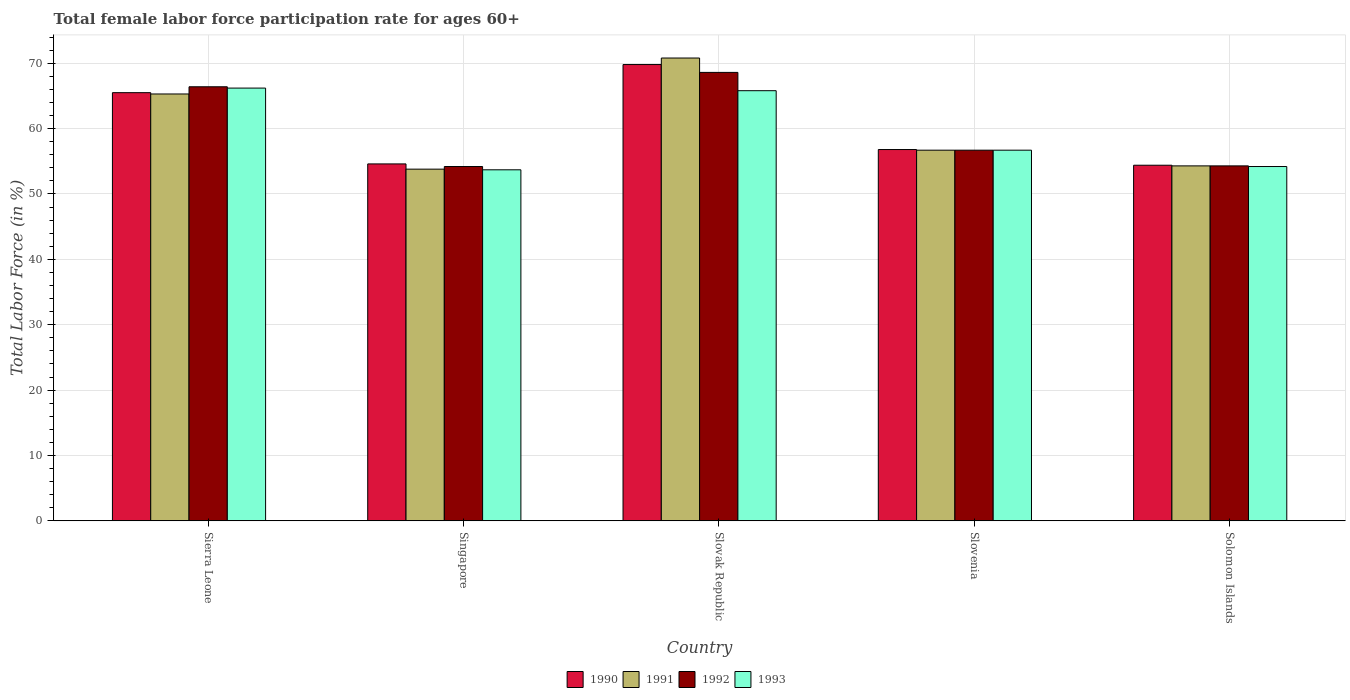How many different coloured bars are there?
Keep it short and to the point. 4. How many bars are there on the 5th tick from the left?
Give a very brief answer. 4. How many bars are there on the 3rd tick from the right?
Give a very brief answer. 4. What is the label of the 1st group of bars from the left?
Provide a succinct answer. Sierra Leone. In how many cases, is the number of bars for a given country not equal to the number of legend labels?
Offer a very short reply. 0. What is the female labor force participation rate in 1990 in Singapore?
Give a very brief answer. 54.6. Across all countries, what is the maximum female labor force participation rate in 1991?
Your answer should be compact. 70.8. Across all countries, what is the minimum female labor force participation rate in 1990?
Offer a very short reply. 54.4. In which country was the female labor force participation rate in 1993 maximum?
Make the answer very short. Sierra Leone. In which country was the female labor force participation rate in 1991 minimum?
Offer a very short reply. Singapore. What is the total female labor force participation rate in 1993 in the graph?
Provide a short and direct response. 296.6. What is the difference between the female labor force participation rate in 1992 in Solomon Islands and the female labor force participation rate in 1990 in Slovenia?
Provide a short and direct response. -2.5. What is the average female labor force participation rate in 1990 per country?
Give a very brief answer. 60.22. What is the difference between the female labor force participation rate of/in 1993 and female labor force participation rate of/in 1992 in Slovenia?
Provide a succinct answer. 0. What is the ratio of the female labor force participation rate in 1990 in Singapore to that in Solomon Islands?
Your answer should be very brief. 1. Is the female labor force participation rate in 1993 in Singapore less than that in Solomon Islands?
Offer a very short reply. Yes. What is the difference between the highest and the second highest female labor force participation rate in 1990?
Provide a short and direct response. -8.7. What is the difference between the highest and the lowest female labor force participation rate in 1991?
Your answer should be compact. 17. In how many countries, is the female labor force participation rate in 1992 greater than the average female labor force participation rate in 1992 taken over all countries?
Ensure brevity in your answer.  2. Is the sum of the female labor force participation rate in 1991 in Singapore and Slovak Republic greater than the maximum female labor force participation rate in 1992 across all countries?
Your answer should be compact. Yes. Is it the case that in every country, the sum of the female labor force participation rate in 1991 and female labor force participation rate in 1993 is greater than the sum of female labor force participation rate in 1992 and female labor force participation rate in 1990?
Make the answer very short. No. What does the 2nd bar from the left in Singapore represents?
Ensure brevity in your answer.  1991. What does the 3rd bar from the right in Solomon Islands represents?
Ensure brevity in your answer.  1991. Is it the case that in every country, the sum of the female labor force participation rate in 1991 and female labor force participation rate in 1993 is greater than the female labor force participation rate in 1992?
Ensure brevity in your answer.  Yes. How many bars are there?
Keep it short and to the point. 20. Are all the bars in the graph horizontal?
Offer a very short reply. No. What is the difference between two consecutive major ticks on the Y-axis?
Provide a succinct answer. 10. Are the values on the major ticks of Y-axis written in scientific E-notation?
Ensure brevity in your answer.  No. Does the graph contain any zero values?
Your answer should be compact. No. How are the legend labels stacked?
Give a very brief answer. Horizontal. What is the title of the graph?
Your answer should be very brief. Total female labor force participation rate for ages 60+. What is the label or title of the X-axis?
Provide a short and direct response. Country. What is the Total Labor Force (in %) in 1990 in Sierra Leone?
Provide a short and direct response. 65.5. What is the Total Labor Force (in %) in 1991 in Sierra Leone?
Ensure brevity in your answer.  65.3. What is the Total Labor Force (in %) of 1992 in Sierra Leone?
Make the answer very short. 66.4. What is the Total Labor Force (in %) in 1993 in Sierra Leone?
Keep it short and to the point. 66.2. What is the Total Labor Force (in %) in 1990 in Singapore?
Your answer should be compact. 54.6. What is the Total Labor Force (in %) of 1991 in Singapore?
Your answer should be compact. 53.8. What is the Total Labor Force (in %) in 1992 in Singapore?
Your answer should be compact. 54.2. What is the Total Labor Force (in %) of 1993 in Singapore?
Give a very brief answer. 53.7. What is the Total Labor Force (in %) in 1990 in Slovak Republic?
Make the answer very short. 69.8. What is the Total Labor Force (in %) of 1991 in Slovak Republic?
Keep it short and to the point. 70.8. What is the Total Labor Force (in %) in 1992 in Slovak Republic?
Provide a succinct answer. 68.6. What is the Total Labor Force (in %) of 1993 in Slovak Republic?
Keep it short and to the point. 65.8. What is the Total Labor Force (in %) in 1990 in Slovenia?
Provide a succinct answer. 56.8. What is the Total Labor Force (in %) in 1991 in Slovenia?
Offer a very short reply. 56.7. What is the Total Labor Force (in %) in 1992 in Slovenia?
Give a very brief answer. 56.7. What is the Total Labor Force (in %) in 1993 in Slovenia?
Provide a succinct answer. 56.7. What is the Total Labor Force (in %) of 1990 in Solomon Islands?
Your answer should be compact. 54.4. What is the Total Labor Force (in %) in 1991 in Solomon Islands?
Provide a succinct answer. 54.3. What is the Total Labor Force (in %) in 1992 in Solomon Islands?
Offer a very short reply. 54.3. What is the Total Labor Force (in %) of 1993 in Solomon Islands?
Keep it short and to the point. 54.2. Across all countries, what is the maximum Total Labor Force (in %) of 1990?
Provide a succinct answer. 69.8. Across all countries, what is the maximum Total Labor Force (in %) in 1991?
Your answer should be compact. 70.8. Across all countries, what is the maximum Total Labor Force (in %) of 1992?
Provide a succinct answer. 68.6. Across all countries, what is the maximum Total Labor Force (in %) of 1993?
Your answer should be compact. 66.2. Across all countries, what is the minimum Total Labor Force (in %) of 1990?
Your response must be concise. 54.4. Across all countries, what is the minimum Total Labor Force (in %) of 1991?
Provide a short and direct response. 53.8. Across all countries, what is the minimum Total Labor Force (in %) in 1992?
Your response must be concise. 54.2. Across all countries, what is the minimum Total Labor Force (in %) of 1993?
Provide a short and direct response. 53.7. What is the total Total Labor Force (in %) of 1990 in the graph?
Ensure brevity in your answer.  301.1. What is the total Total Labor Force (in %) of 1991 in the graph?
Offer a terse response. 300.9. What is the total Total Labor Force (in %) of 1992 in the graph?
Provide a succinct answer. 300.2. What is the total Total Labor Force (in %) in 1993 in the graph?
Provide a short and direct response. 296.6. What is the difference between the Total Labor Force (in %) of 1990 in Sierra Leone and that in Singapore?
Your response must be concise. 10.9. What is the difference between the Total Labor Force (in %) in 1992 in Sierra Leone and that in Singapore?
Offer a very short reply. 12.2. What is the difference between the Total Labor Force (in %) of 1991 in Sierra Leone and that in Slovak Republic?
Your answer should be very brief. -5.5. What is the difference between the Total Labor Force (in %) in 1992 in Sierra Leone and that in Slovak Republic?
Keep it short and to the point. -2.2. What is the difference between the Total Labor Force (in %) of 1993 in Sierra Leone and that in Slovak Republic?
Your response must be concise. 0.4. What is the difference between the Total Labor Force (in %) of 1990 in Sierra Leone and that in Slovenia?
Your response must be concise. 8.7. What is the difference between the Total Labor Force (in %) in 1991 in Sierra Leone and that in Slovenia?
Ensure brevity in your answer.  8.6. What is the difference between the Total Labor Force (in %) in 1992 in Sierra Leone and that in Slovenia?
Your answer should be compact. 9.7. What is the difference between the Total Labor Force (in %) of 1992 in Sierra Leone and that in Solomon Islands?
Ensure brevity in your answer.  12.1. What is the difference between the Total Labor Force (in %) of 1993 in Sierra Leone and that in Solomon Islands?
Ensure brevity in your answer.  12. What is the difference between the Total Labor Force (in %) in 1990 in Singapore and that in Slovak Republic?
Keep it short and to the point. -15.2. What is the difference between the Total Labor Force (in %) of 1991 in Singapore and that in Slovak Republic?
Make the answer very short. -17. What is the difference between the Total Labor Force (in %) of 1992 in Singapore and that in Slovak Republic?
Provide a short and direct response. -14.4. What is the difference between the Total Labor Force (in %) in 1993 in Singapore and that in Slovak Republic?
Ensure brevity in your answer.  -12.1. What is the difference between the Total Labor Force (in %) of 1990 in Singapore and that in Slovenia?
Make the answer very short. -2.2. What is the difference between the Total Labor Force (in %) of 1991 in Singapore and that in Slovenia?
Your answer should be very brief. -2.9. What is the difference between the Total Labor Force (in %) of 1993 in Singapore and that in Slovenia?
Offer a terse response. -3. What is the difference between the Total Labor Force (in %) of 1991 in Singapore and that in Solomon Islands?
Provide a short and direct response. -0.5. What is the difference between the Total Labor Force (in %) of 1992 in Singapore and that in Solomon Islands?
Your answer should be very brief. -0.1. What is the difference between the Total Labor Force (in %) in 1991 in Slovak Republic and that in Slovenia?
Ensure brevity in your answer.  14.1. What is the difference between the Total Labor Force (in %) in 1992 in Slovak Republic and that in Slovenia?
Make the answer very short. 11.9. What is the difference between the Total Labor Force (in %) in 1991 in Slovak Republic and that in Solomon Islands?
Provide a short and direct response. 16.5. What is the difference between the Total Labor Force (in %) of 1991 in Slovenia and that in Solomon Islands?
Make the answer very short. 2.4. What is the difference between the Total Labor Force (in %) in 1992 in Slovenia and that in Solomon Islands?
Your answer should be compact. 2.4. What is the difference between the Total Labor Force (in %) in 1993 in Slovenia and that in Solomon Islands?
Your answer should be very brief. 2.5. What is the difference between the Total Labor Force (in %) in 1990 in Sierra Leone and the Total Labor Force (in %) in 1993 in Singapore?
Your response must be concise. 11.8. What is the difference between the Total Labor Force (in %) in 1990 in Sierra Leone and the Total Labor Force (in %) in 1993 in Slovak Republic?
Keep it short and to the point. -0.3. What is the difference between the Total Labor Force (in %) in 1991 in Sierra Leone and the Total Labor Force (in %) in 1993 in Slovak Republic?
Offer a very short reply. -0.5. What is the difference between the Total Labor Force (in %) in 1990 in Sierra Leone and the Total Labor Force (in %) in 1991 in Slovenia?
Provide a short and direct response. 8.8. What is the difference between the Total Labor Force (in %) of 1990 in Sierra Leone and the Total Labor Force (in %) of 1993 in Slovenia?
Provide a succinct answer. 8.8. What is the difference between the Total Labor Force (in %) in 1991 in Sierra Leone and the Total Labor Force (in %) in 1993 in Slovenia?
Give a very brief answer. 8.6. What is the difference between the Total Labor Force (in %) in 1992 in Sierra Leone and the Total Labor Force (in %) in 1993 in Slovenia?
Keep it short and to the point. 9.7. What is the difference between the Total Labor Force (in %) in 1990 in Sierra Leone and the Total Labor Force (in %) in 1992 in Solomon Islands?
Offer a very short reply. 11.2. What is the difference between the Total Labor Force (in %) in 1990 in Sierra Leone and the Total Labor Force (in %) in 1993 in Solomon Islands?
Your answer should be compact. 11.3. What is the difference between the Total Labor Force (in %) of 1991 in Sierra Leone and the Total Labor Force (in %) of 1993 in Solomon Islands?
Your response must be concise. 11.1. What is the difference between the Total Labor Force (in %) of 1992 in Sierra Leone and the Total Labor Force (in %) of 1993 in Solomon Islands?
Offer a very short reply. 12.2. What is the difference between the Total Labor Force (in %) in 1990 in Singapore and the Total Labor Force (in %) in 1991 in Slovak Republic?
Keep it short and to the point. -16.2. What is the difference between the Total Labor Force (in %) of 1990 in Singapore and the Total Labor Force (in %) of 1992 in Slovak Republic?
Give a very brief answer. -14. What is the difference between the Total Labor Force (in %) of 1990 in Singapore and the Total Labor Force (in %) of 1993 in Slovak Republic?
Keep it short and to the point. -11.2. What is the difference between the Total Labor Force (in %) of 1991 in Singapore and the Total Labor Force (in %) of 1992 in Slovak Republic?
Provide a short and direct response. -14.8. What is the difference between the Total Labor Force (in %) of 1991 in Singapore and the Total Labor Force (in %) of 1993 in Slovak Republic?
Offer a terse response. -12. What is the difference between the Total Labor Force (in %) of 1990 in Singapore and the Total Labor Force (in %) of 1991 in Slovenia?
Offer a terse response. -2.1. What is the difference between the Total Labor Force (in %) of 1990 in Singapore and the Total Labor Force (in %) of 1992 in Slovenia?
Your answer should be compact. -2.1. What is the difference between the Total Labor Force (in %) in 1990 in Singapore and the Total Labor Force (in %) in 1993 in Slovenia?
Give a very brief answer. -2.1. What is the difference between the Total Labor Force (in %) of 1991 in Singapore and the Total Labor Force (in %) of 1992 in Slovenia?
Give a very brief answer. -2.9. What is the difference between the Total Labor Force (in %) in 1991 in Singapore and the Total Labor Force (in %) in 1993 in Slovenia?
Give a very brief answer. -2.9. What is the difference between the Total Labor Force (in %) in 1990 in Singapore and the Total Labor Force (in %) in 1991 in Solomon Islands?
Keep it short and to the point. 0.3. What is the difference between the Total Labor Force (in %) of 1990 in Singapore and the Total Labor Force (in %) of 1992 in Solomon Islands?
Offer a terse response. 0.3. What is the difference between the Total Labor Force (in %) in 1991 in Singapore and the Total Labor Force (in %) in 1992 in Solomon Islands?
Your answer should be very brief. -0.5. What is the difference between the Total Labor Force (in %) of 1991 in Singapore and the Total Labor Force (in %) of 1993 in Solomon Islands?
Offer a very short reply. -0.4. What is the difference between the Total Labor Force (in %) of 1990 in Slovak Republic and the Total Labor Force (in %) of 1993 in Slovenia?
Offer a terse response. 13.1. What is the difference between the Total Labor Force (in %) of 1991 in Slovak Republic and the Total Labor Force (in %) of 1993 in Slovenia?
Ensure brevity in your answer.  14.1. What is the difference between the Total Labor Force (in %) in 1990 in Slovak Republic and the Total Labor Force (in %) in 1993 in Solomon Islands?
Your response must be concise. 15.6. What is the difference between the Total Labor Force (in %) of 1991 in Slovak Republic and the Total Labor Force (in %) of 1993 in Solomon Islands?
Ensure brevity in your answer.  16.6. What is the difference between the Total Labor Force (in %) of 1990 in Slovenia and the Total Labor Force (in %) of 1991 in Solomon Islands?
Your answer should be very brief. 2.5. What is the difference between the Total Labor Force (in %) of 1990 in Slovenia and the Total Labor Force (in %) of 1992 in Solomon Islands?
Give a very brief answer. 2.5. What is the difference between the Total Labor Force (in %) in 1992 in Slovenia and the Total Labor Force (in %) in 1993 in Solomon Islands?
Make the answer very short. 2.5. What is the average Total Labor Force (in %) in 1990 per country?
Give a very brief answer. 60.22. What is the average Total Labor Force (in %) of 1991 per country?
Your answer should be compact. 60.18. What is the average Total Labor Force (in %) of 1992 per country?
Keep it short and to the point. 60.04. What is the average Total Labor Force (in %) of 1993 per country?
Offer a terse response. 59.32. What is the difference between the Total Labor Force (in %) in 1990 and Total Labor Force (in %) in 1993 in Sierra Leone?
Provide a succinct answer. -0.7. What is the difference between the Total Labor Force (in %) of 1991 and Total Labor Force (in %) of 1992 in Sierra Leone?
Offer a terse response. -1.1. What is the difference between the Total Labor Force (in %) of 1991 and Total Labor Force (in %) of 1992 in Singapore?
Your answer should be compact. -0.4. What is the difference between the Total Labor Force (in %) in 1991 and Total Labor Force (in %) in 1992 in Slovak Republic?
Provide a short and direct response. 2.2. What is the difference between the Total Labor Force (in %) of 1991 and Total Labor Force (in %) of 1993 in Slovak Republic?
Your response must be concise. 5. What is the difference between the Total Labor Force (in %) of 1992 and Total Labor Force (in %) of 1993 in Slovak Republic?
Provide a short and direct response. 2.8. What is the difference between the Total Labor Force (in %) of 1990 and Total Labor Force (in %) of 1992 in Slovenia?
Offer a very short reply. 0.1. What is the difference between the Total Labor Force (in %) in 1990 and Total Labor Force (in %) in 1993 in Slovenia?
Your answer should be very brief. 0.1. What is the difference between the Total Labor Force (in %) of 1991 and Total Labor Force (in %) of 1992 in Slovenia?
Provide a succinct answer. 0. What is the difference between the Total Labor Force (in %) in 1990 and Total Labor Force (in %) in 1991 in Solomon Islands?
Give a very brief answer. 0.1. What is the difference between the Total Labor Force (in %) of 1990 and Total Labor Force (in %) of 1992 in Solomon Islands?
Offer a terse response. 0.1. What is the difference between the Total Labor Force (in %) of 1991 and Total Labor Force (in %) of 1992 in Solomon Islands?
Your answer should be compact. 0. What is the difference between the Total Labor Force (in %) of 1991 and Total Labor Force (in %) of 1993 in Solomon Islands?
Offer a very short reply. 0.1. What is the difference between the Total Labor Force (in %) of 1992 and Total Labor Force (in %) of 1993 in Solomon Islands?
Your response must be concise. 0.1. What is the ratio of the Total Labor Force (in %) of 1990 in Sierra Leone to that in Singapore?
Provide a succinct answer. 1.2. What is the ratio of the Total Labor Force (in %) in 1991 in Sierra Leone to that in Singapore?
Ensure brevity in your answer.  1.21. What is the ratio of the Total Labor Force (in %) of 1992 in Sierra Leone to that in Singapore?
Offer a very short reply. 1.23. What is the ratio of the Total Labor Force (in %) of 1993 in Sierra Leone to that in Singapore?
Your response must be concise. 1.23. What is the ratio of the Total Labor Force (in %) in 1990 in Sierra Leone to that in Slovak Republic?
Offer a terse response. 0.94. What is the ratio of the Total Labor Force (in %) in 1991 in Sierra Leone to that in Slovak Republic?
Your answer should be compact. 0.92. What is the ratio of the Total Labor Force (in %) of 1992 in Sierra Leone to that in Slovak Republic?
Keep it short and to the point. 0.97. What is the ratio of the Total Labor Force (in %) in 1990 in Sierra Leone to that in Slovenia?
Your response must be concise. 1.15. What is the ratio of the Total Labor Force (in %) of 1991 in Sierra Leone to that in Slovenia?
Give a very brief answer. 1.15. What is the ratio of the Total Labor Force (in %) of 1992 in Sierra Leone to that in Slovenia?
Keep it short and to the point. 1.17. What is the ratio of the Total Labor Force (in %) in 1993 in Sierra Leone to that in Slovenia?
Ensure brevity in your answer.  1.17. What is the ratio of the Total Labor Force (in %) in 1990 in Sierra Leone to that in Solomon Islands?
Your answer should be compact. 1.2. What is the ratio of the Total Labor Force (in %) of 1991 in Sierra Leone to that in Solomon Islands?
Provide a short and direct response. 1.2. What is the ratio of the Total Labor Force (in %) in 1992 in Sierra Leone to that in Solomon Islands?
Your answer should be compact. 1.22. What is the ratio of the Total Labor Force (in %) in 1993 in Sierra Leone to that in Solomon Islands?
Keep it short and to the point. 1.22. What is the ratio of the Total Labor Force (in %) in 1990 in Singapore to that in Slovak Republic?
Your answer should be very brief. 0.78. What is the ratio of the Total Labor Force (in %) in 1991 in Singapore to that in Slovak Republic?
Your answer should be very brief. 0.76. What is the ratio of the Total Labor Force (in %) in 1992 in Singapore to that in Slovak Republic?
Your answer should be compact. 0.79. What is the ratio of the Total Labor Force (in %) of 1993 in Singapore to that in Slovak Republic?
Ensure brevity in your answer.  0.82. What is the ratio of the Total Labor Force (in %) in 1990 in Singapore to that in Slovenia?
Make the answer very short. 0.96. What is the ratio of the Total Labor Force (in %) of 1991 in Singapore to that in Slovenia?
Keep it short and to the point. 0.95. What is the ratio of the Total Labor Force (in %) of 1992 in Singapore to that in Slovenia?
Make the answer very short. 0.96. What is the ratio of the Total Labor Force (in %) in 1993 in Singapore to that in Slovenia?
Ensure brevity in your answer.  0.95. What is the ratio of the Total Labor Force (in %) of 1991 in Singapore to that in Solomon Islands?
Offer a very short reply. 0.99. What is the ratio of the Total Labor Force (in %) of 1990 in Slovak Republic to that in Slovenia?
Make the answer very short. 1.23. What is the ratio of the Total Labor Force (in %) of 1991 in Slovak Republic to that in Slovenia?
Make the answer very short. 1.25. What is the ratio of the Total Labor Force (in %) in 1992 in Slovak Republic to that in Slovenia?
Keep it short and to the point. 1.21. What is the ratio of the Total Labor Force (in %) in 1993 in Slovak Republic to that in Slovenia?
Provide a succinct answer. 1.16. What is the ratio of the Total Labor Force (in %) in 1990 in Slovak Republic to that in Solomon Islands?
Give a very brief answer. 1.28. What is the ratio of the Total Labor Force (in %) of 1991 in Slovak Republic to that in Solomon Islands?
Your response must be concise. 1.3. What is the ratio of the Total Labor Force (in %) in 1992 in Slovak Republic to that in Solomon Islands?
Offer a terse response. 1.26. What is the ratio of the Total Labor Force (in %) of 1993 in Slovak Republic to that in Solomon Islands?
Your answer should be very brief. 1.21. What is the ratio of the Total Labor Force (in %) in 1990 in Slovenia to that in Solomon Islands?
Your response must be concise. 1.04. What is the ratio of the Total Labor Force (in %) of 1991 in Slovenia to that in Solomon Islands?
Provide a succinct answer. 1.04. What is the ratio of the Total Labor Force (in %) of 1992 in Slovenia to that in Solomon Islands?
Your answer should be compact. 1.04. What is the ratio of the Total Labor Force (in %) in 1993 in Slovenia to that in Solomon Islands?
Make the answer very short. 1.05. What is the difference between the highest and the second highest Total Labor Force (in %) in 1990?
Ensure brevity in your answer.  4.3. What is the difference between the highest and the second highest Total Labor Force (in %) of 1992?
Ensure brevity in your answer.  2.2. What is the difference between the highest and the second highest Total Labor Force (in %) in 1993?
Your answer should be very brief. 0.4. What is the difference between the highest and the lowest Total Labor Force (in %) in 1992?
Offer a very short reply. 14.4. What is the difference between the highest and the lowest Total Labor Force (in %) in 1993?
Your answer should be compact. 12.5. 